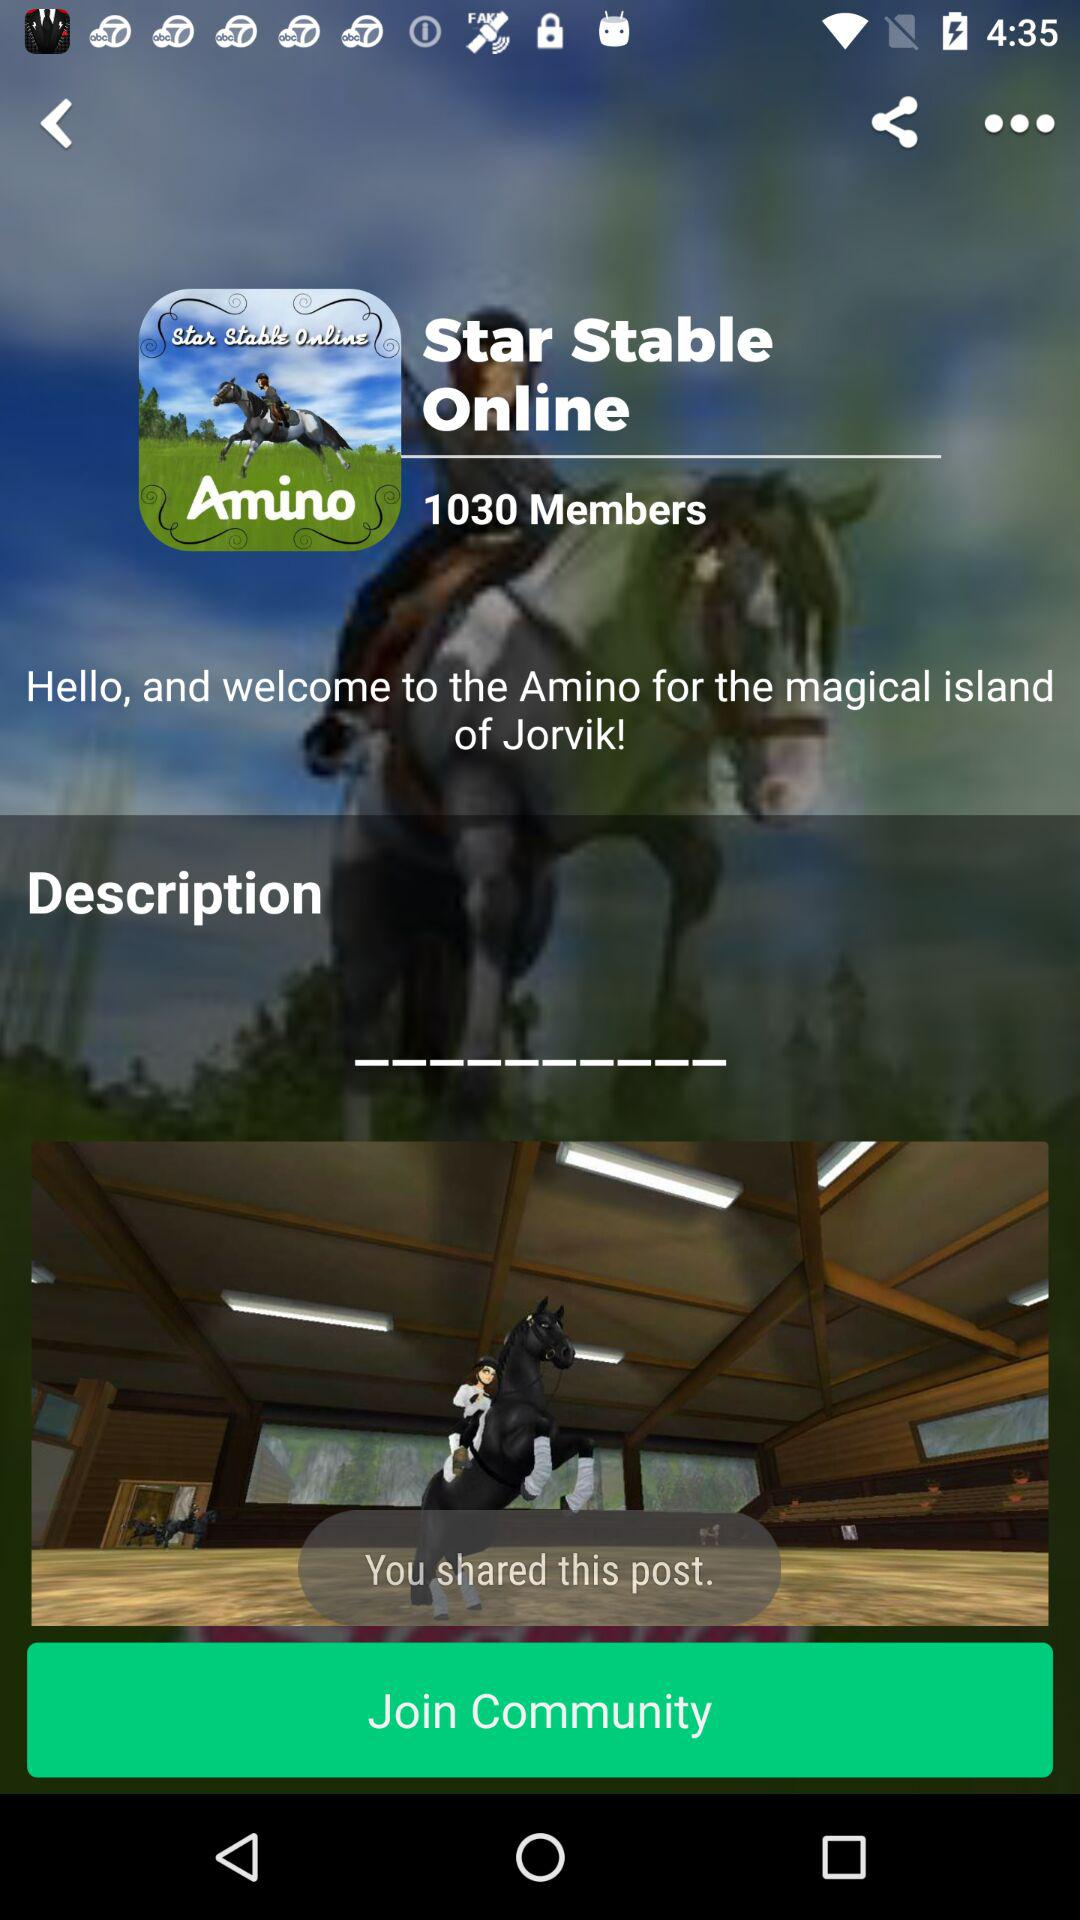What is the count of members? The count is 1030. 